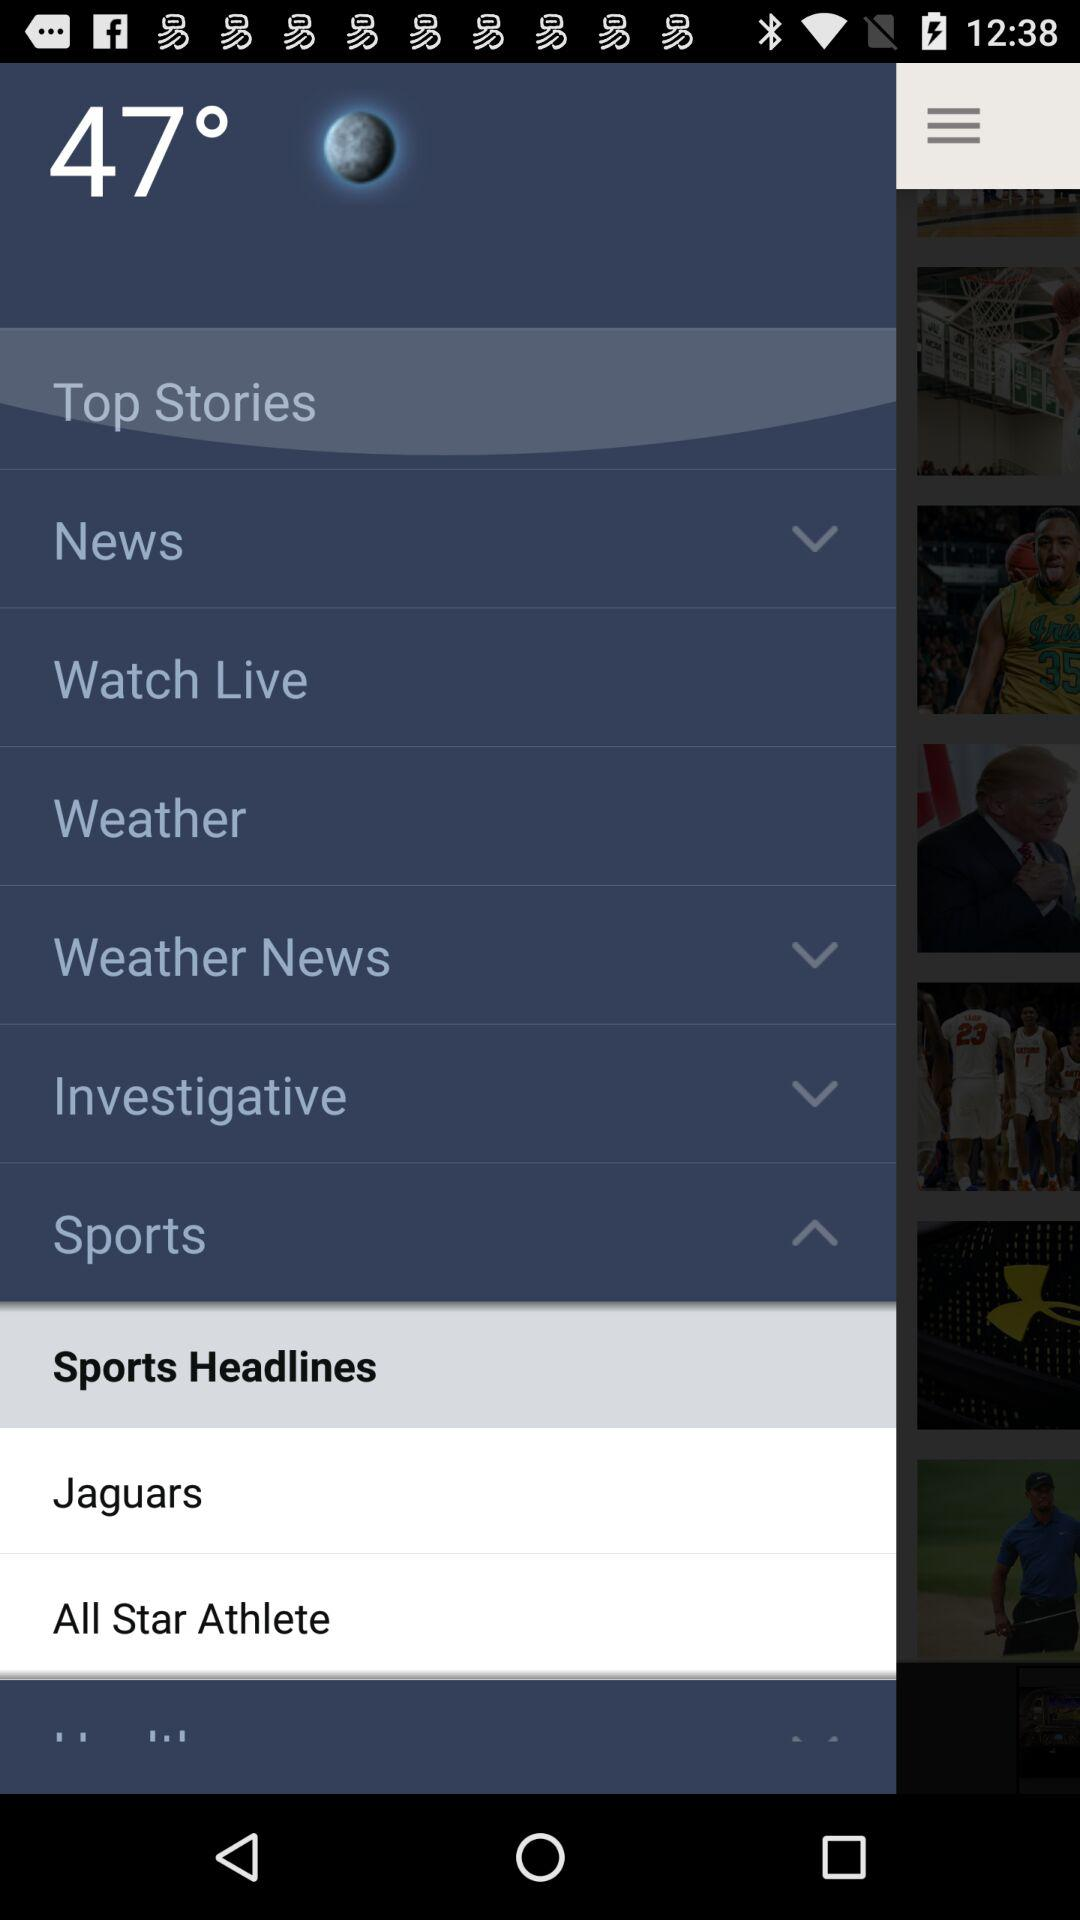What is the temperature? The temperature is 47 degrees. 